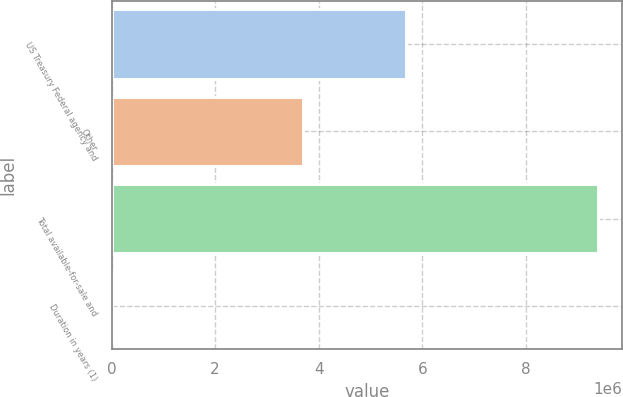<chart> <loc_0><loc_0><loc_500><loc_500><bar_chart><fcel>US Treasury Federal agency and<fcel>Other<fcel>Total available-for-sale and<fcel>Duration in years (1)<nl><fcel>5.6797e+06<fcel>3.70497e+06<fcel>9.38467e+06<fcel>3.9<nl></chart> 